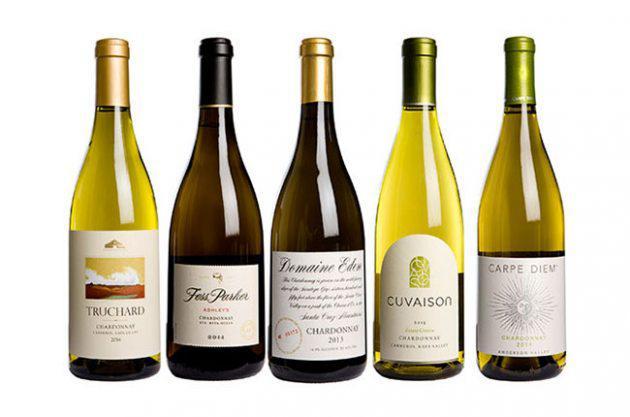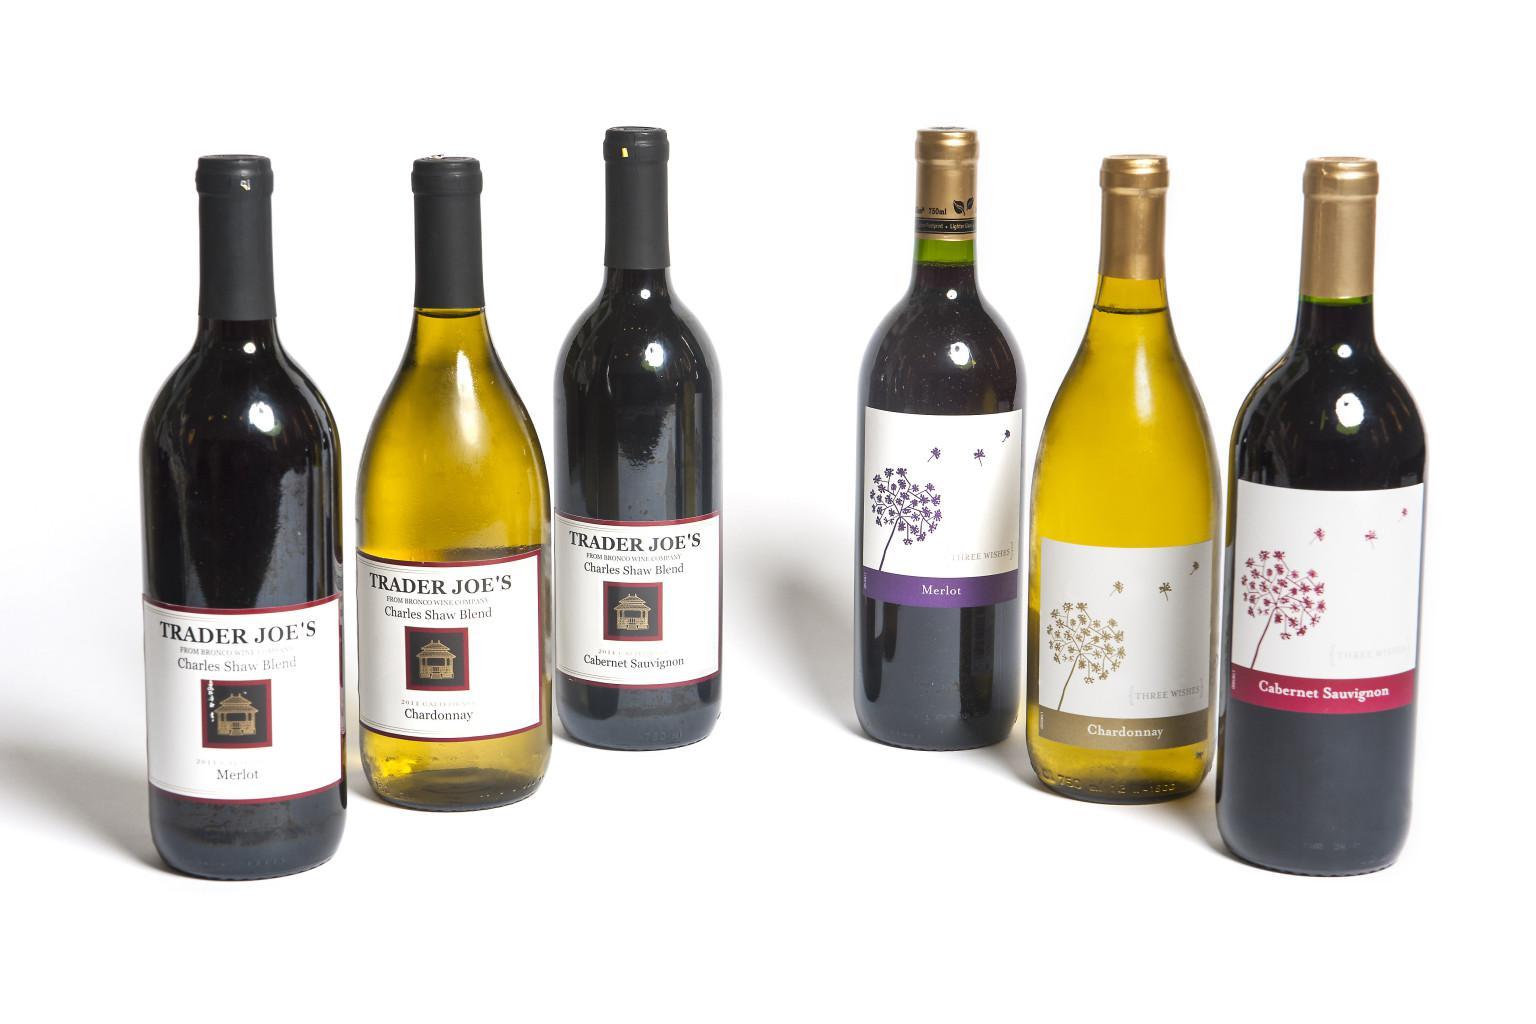The first image is the image on the left, the second image is the image on the right. Assess this claim about the two images: "The image on the left has a bottle of red colored wine sitting in the center of a group of 5 wine bottles.". Correct or not? Answer yes or no. No. The first image is the image on the left, the second image is the image on the right. For the images shown, is this caption "An image shows bottles arranged with the center one closest to the camera, and no bottles touching or identical." true? Answer yes or no. No. 